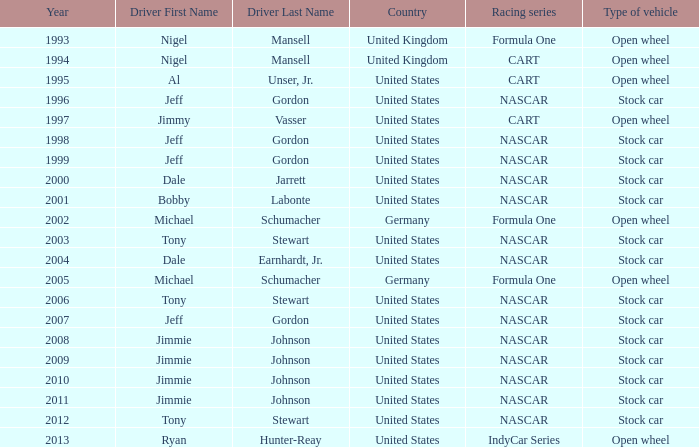Would you mind parsing the complete table? {'header': ['Year', 'Driver First Name', 'Driver Last Name', 'Country', 'Racing series', 'Type of vehicle'], 'rows': [['1993', 'Nigel', 'Mansell', 'United Kingdom', 'Formula One', 'Open wheel'], ['1994', 'Nigel', 'Mansell', 'United Kingdom', 'CART', 'Open wheel'], ['1995', 'Al', 'Unser, Jr.', 'United States', 'CART', 'Open wheel'], ['1996', 'Jeff', 'Gordon', 'United States', 'NASCAR', 'Stock car'], ['1997', 'Jimmy', 'Vasser', 'United States', 'CART', 'Open wheel'], ['1998', 'Jeff', 'Gordon', 'United States', 'NASCAR', 'Stock car'], ['1999', 'Jeff', 'Gordon', 'United States', 'NASCAR', 'Stock car'], ['2000', 'Dale', 'Jarrett', 'United States', 'NASCAR', 'Stock car'], ['2001', 'Bobby', 'Labonte', 'United States', 'NASCAR', 'Stock car'], ['2002', 'Michael', 'Schumacher', 'Germany', 'Formula One', 'Open wheel'], ['2003', 'Tony', 'Stewart', 'United States', 'NASCAR', 'Stock car'], ['2004', 'Dale', 'Earnhardt, Jr.', 'United States', 'NASCAR', 'Stock car'], ['2005', 'Michael', 'Schumacher', 'Germany', 'Formula One', 'Open wheel'], ['2006', 'Tony', 'Stewart', 'United States', 'NASCAR', 'Stock car'], ['2007', 'Jeff', 'Gordon', 'United States', 'NASCAR', 'Stock car'], ['2008', 'Jimmie', 'Johnson', 'United States', 'NASCAR', 'Stock car'], ['2009', 'Jimmie', 'Johnson', 'United States', 'NASCAR', 'Stock car'], ['2010', 'Jimmie', 'Johnson', 'United States', 'NASCAR', 'Stock car'], ['2011', 'Jimmie', 'Johnson', 'United States', 'NASCAR', 'Stock car'], ['2012', 'Tony', 'Stewart', 'United States', 'NASCAR', 'Stock car'], ['2013', 'Ryan', 'Hunter-Reay', 'United States', 'IndyCar Series', 'Open wheel']]} What driver has a stock car vehicle with a year of 1999? Jeff Gordon. 